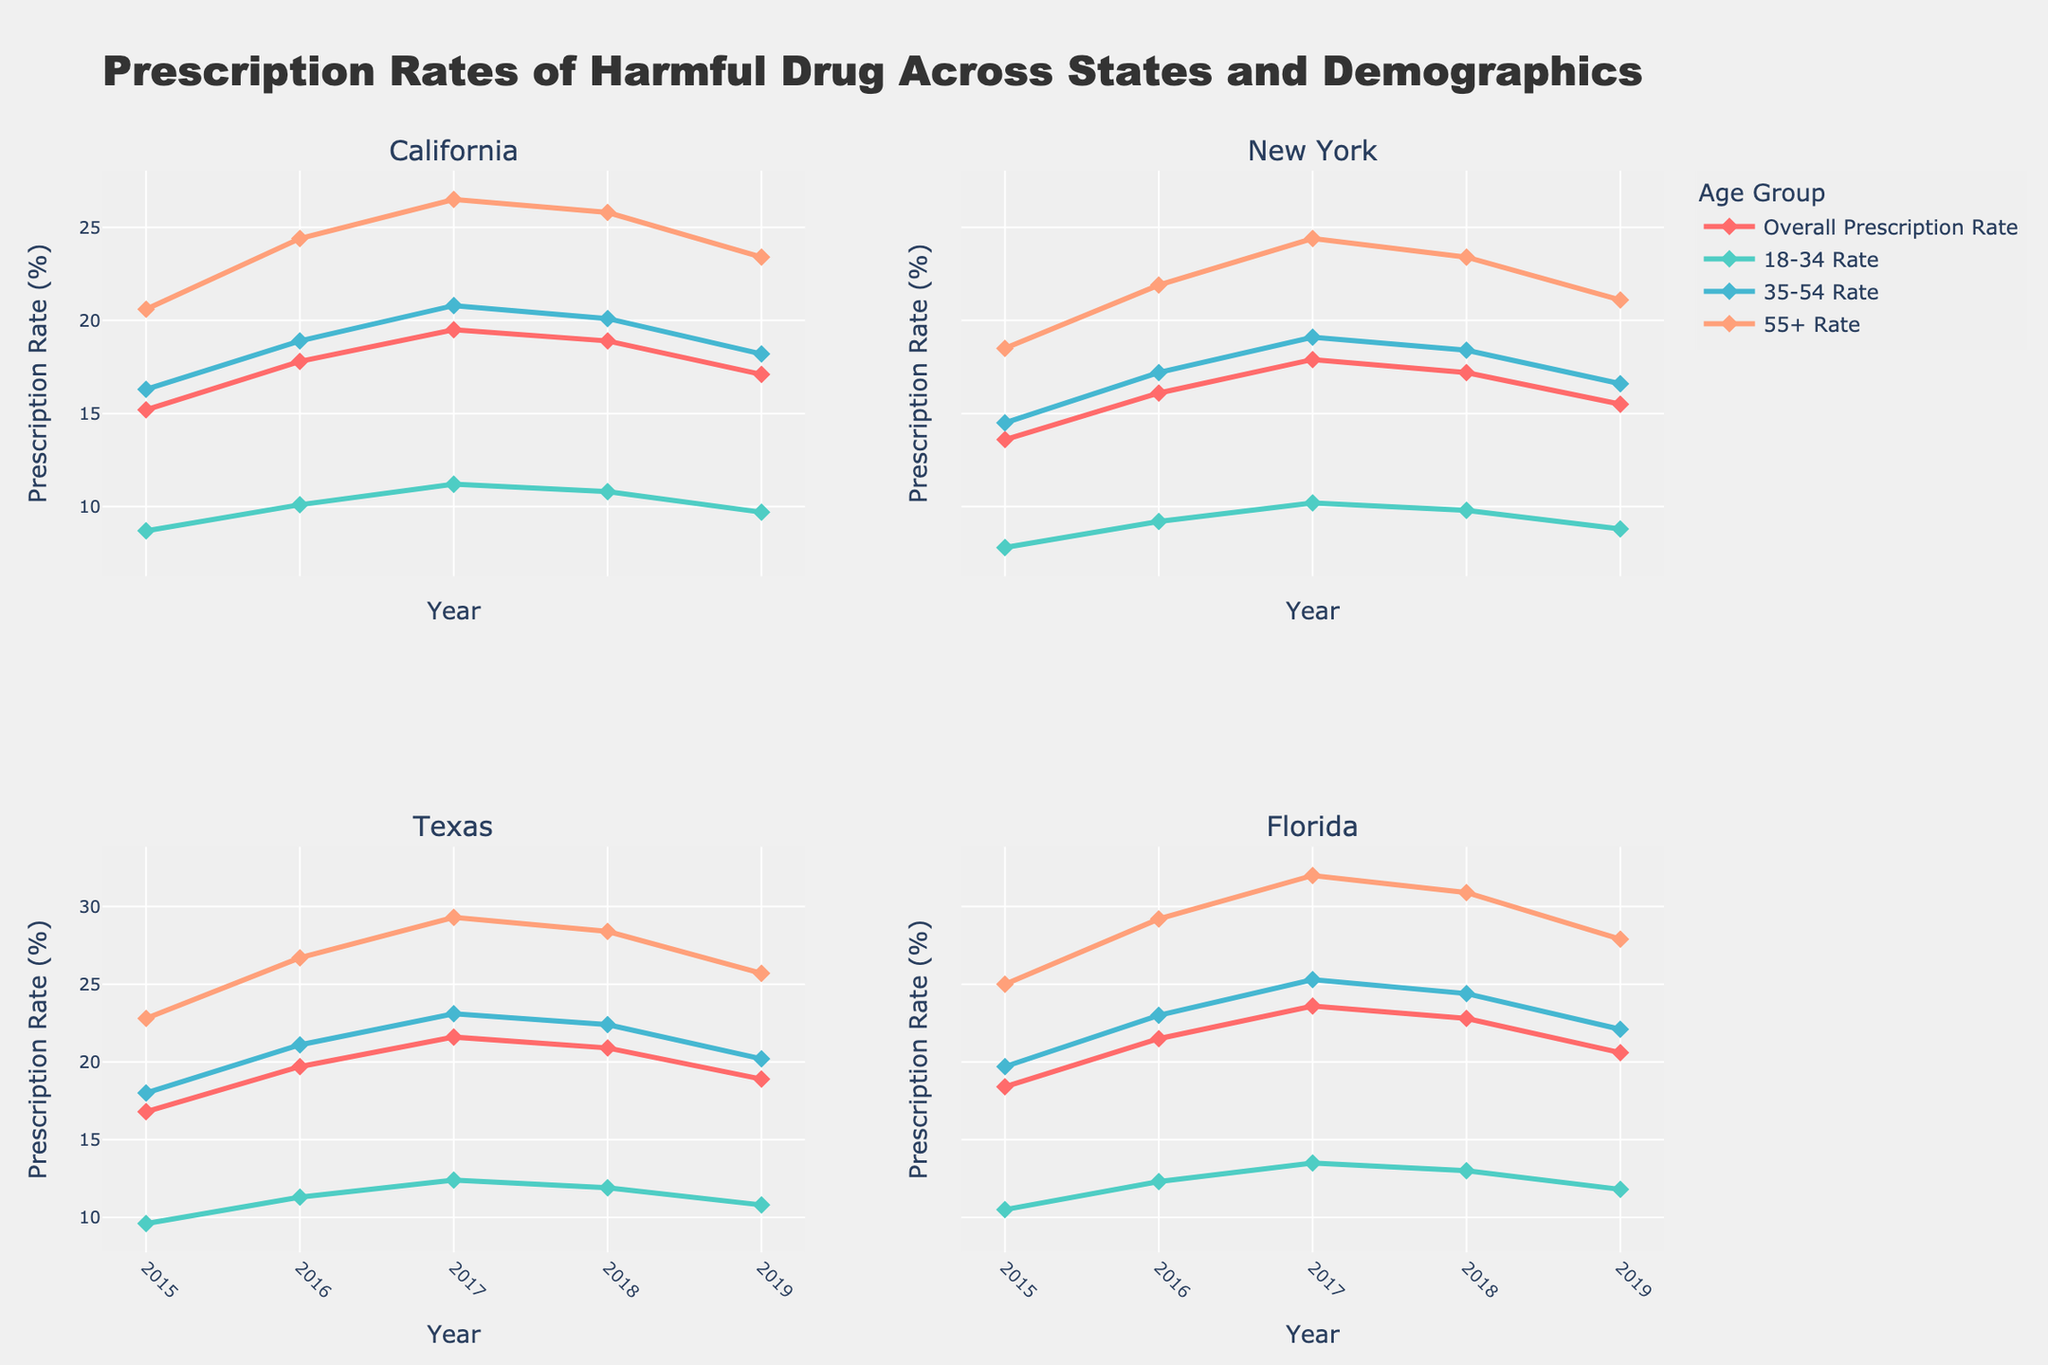How did the prescription rate for the 18-34 age group in California change between 2015 and 2019? Observe the 18-34 Rate for California in 2015 (8.7) and 2019 (9.7). Calculate the change: 9.7 - 8.7 = 1.0
Answer: Increased by 1.0 Which state registered the highest overall prescription rate in 2017? Look for the highest overall prescription rate across states in 2017: California (19.5), New York (17.9), Texas (21.6), Florida (23.6). Compare and identify the highest value which is Florida (23.6)
Answer: Florida How did the prescription rates for the 55+ group in New York trend from 2015 to 2019? Track the prescription rates for the 55+ group in New York: 2015 (18.5), 2016 (21.9), 2017 (24.4), 2018 (23.4), 2019 (21.1). Observe the trend: increases from 2015 to 2017, then decreases from 2017 to 2019
Answer: Increased, then decreased Which age group in Texas exhibited the most consistent upward trend from 2015 to 2017? Look at the 2015 to 2017 trend in Texas for each age group: 18-34 (9.6 to 12.4), 35-54 (18.0 to 23.1), 55+ (22.8 to 29.3). All groups show an increase, but the 55+ group shows the most linear and consistent upward trend
Answer: 55+ age group Compare the 2018 overall prescription rates in California and New York. Which state had a higher rate? Identify the 2018 overall prescription rates: California (18.9), New York (17.2). Compare the two values. California had a higher rate (18.9 > 17.2)
Answer: California What was the average overall prescription rate in Florida from 2015 to 2019? Calculate the sum of yearly overall prescription rates in Florida and then find the average: (18.4 + 21.5 + 23.6 + 22.8 + 20.6) / 5 = 106.9 / 5 = 21.38
Answer: 21.38 Did the 35-54 age group in Texas have a higher prescription rate in 2016 or 2019? Compare the 35-54 Rate in Texas for 2016 (21.1) and 2019 (20.2). The higher rate is in 2016
Answer: 2016 Which age group had the lowest prescription rate in New York in 2019? Examine the data for New York in 2019: 18-34 (8.8), 35-54 (16.6), 55+ (21.1). The lowest rate is for the 18-34 age group (8.8)
Answer: 18-34 age group What was the combined prescription rate for the 35-54 age group in California and Texas in 2017? Add the 35-54 prescription rates for California (20.8) and Texas (23.1) in 2017: 20.8 + 23.1 = 43.9
Answer: 43.9 